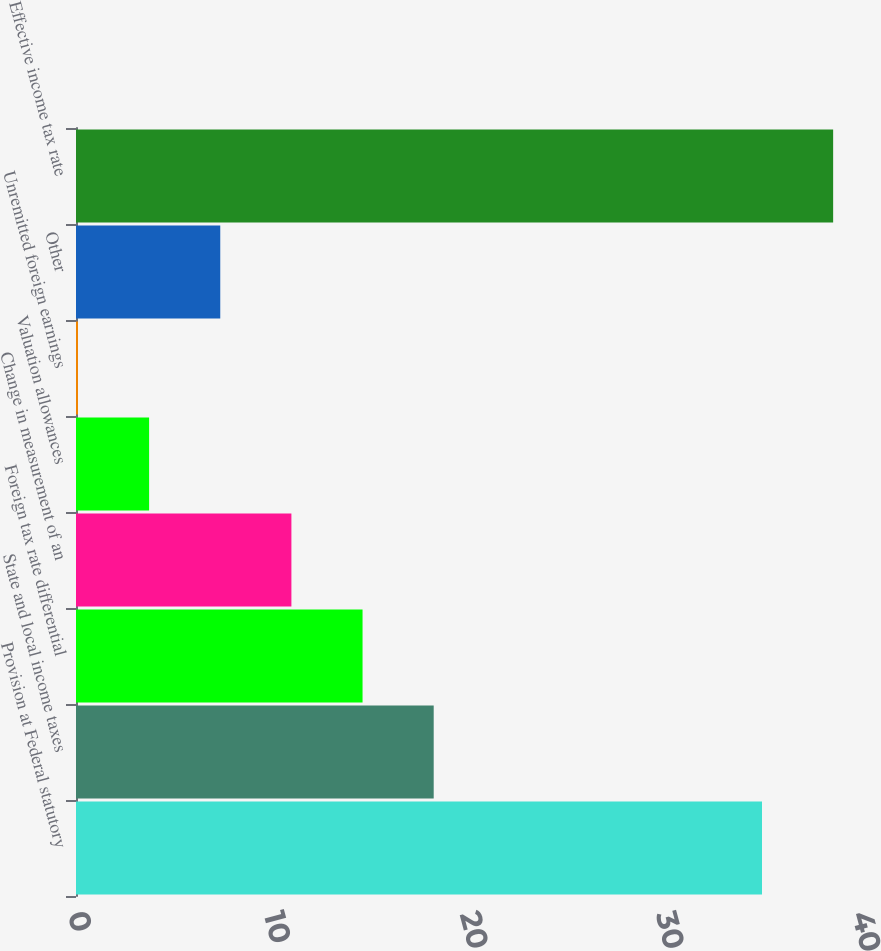<chart> <loc_0><loc_0><loc_500><loc_500><bar_chart><fcel>Provision at Federal statutory<fcel>State and local income taxes<fcel>Foreign tax rate differential<fcel>Change in measurement of an<fcel>Valuation allowances<fcel>Unremitted foreign earnings<fcel>Other<fcel>Effective income tax rate<nl><fcel>35<fcel>18.25<fcel>14.62<fcel>10.99<fcel>3.73<fcel>0.1<fcel>7.36<fcel>38.63<nl></chart> 